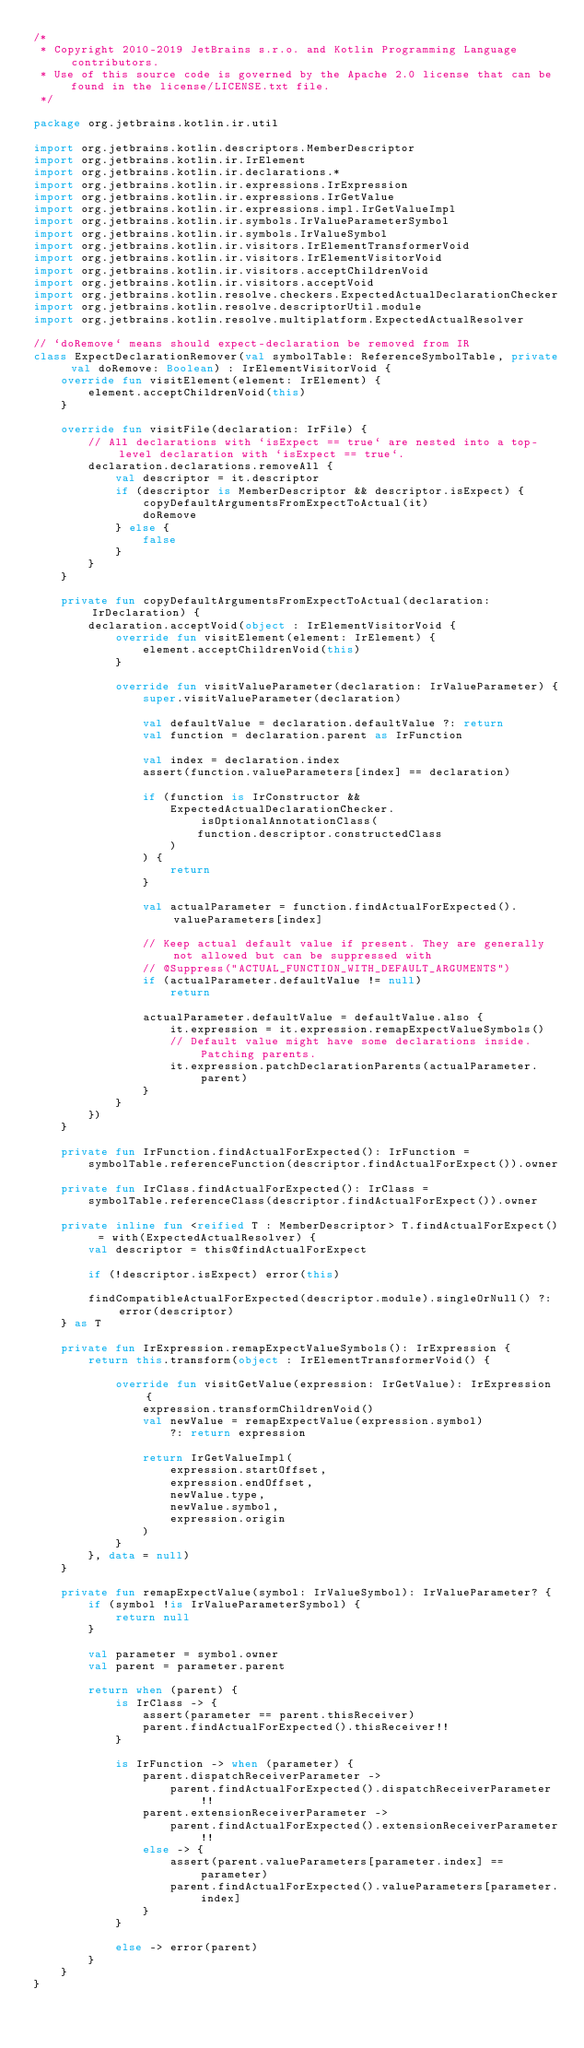<code> <loc_0><loc_0><loc_500><loc_500><_Kotlin_>/*
 * Copyright 2010-2019 JetBrains s.r.o. and Kotlin Programming Language contributors.
 * Use of this source code is governed by the Apache 2.0 license that can be found in the license/LICENSE.txt file.
 */

package org.jetbrains.kotlin.ir.util

import org.jetbrains.kotlin.descriptors.MemberDescriptor
import org.jetbrains.kotlin.ir.IrElement
import org.jetbrains.kotlin.ir.declarations.*
import org.jetbrains.kotlin.ir.expressions.IrExpression
import org.jetbrains.kotlin.ir.expressions.IrGetValue
import org.jetbrains.kotlin.ir.expressions.impl.IrGetValueImpl
import org.jetbrains.kotlin.ir.symbols.IrValueParameterSymbol
import org.jetbrains.kotlin.ir.symbols.IrValueSymbol
import org.jetbrains.kotlin.ir.visitors.IrElementTransformerVoid
import org.jetbrains.kotlin.ir.visitors.IrElementVisitorVoid
import org.jetbrains.kotlin.ir.visitors.acceptChildrenVoid
import org.jetbrains.kotlin.ir.visitors.acceptVoid
import org.jetbrains.kotlin.resolve.checkers.ExpectedActualDeclarationChecker
import org.jetbrains.kotlin.resolve.descriptorUtil.module
import org.jetbrains.kotlin.resolve.multiplatform.ExpectedActualResolver

// `doRemove` means should expect-declaration be removed from IR
class ExpectDeclarationRemover(val symbolTable: ReferenceSymbolTable, private val doRemove: Boolean) : IrElementVisitorVoid {
    override fun visitElement(element: IrElement) {
        element.acceptChildrenVoid(this)
    }

    override fun visitFile(declaration: IrFile) {
        // All declarations with `isExpect == true` are nested into a top-level declaration with `isExpect == true`.
        declaration.declarations.removeAll {
            val descriptor = it.descriptor
            if (descriptor is MemberDescriptor && descriptor.isExpect) {
                copyDefaultArgumentsFromExpectToActual(it)
                doRemove
            } else {
                false
            }
        }
    }

    private fun copyDefaultArgumentsFromExpectToActual(declaration: IrDeclaration) {
        declaration.acceptVoid(object : IrElementVisitorVoid {
            override fun visitElement(element: IrElement) {
                element.acceptChildrenVoid(this)
            }

            override fun visitValueParameter(declaration: IrValueParameter) {
                super.visitValueParameter(declaration)

                val defaultValue = declaration.defaultValue ?: return
                val function = declaration.parent as IrFunction

                val index = declaration.index
                assert(function.valueParameters[index] == declaration)

                if (function is IrConstructor &&
                    ExpectedActualDeclarationChecker.isOptionalAnnotationClass(
                        function.descriptor.constructedClass
                    )
                ) {
                    return
                }

                val actualParameter = function.findActualForExpected().valueParameters[index]

                // Keep actual default value if present. They are generally not allowed but can be suppressed with
                // @Suppress("ACTUAL_FUNCTION_WITH_DEFAULT_ARGUMENTS")
                if (actualParameter.defaultValue != null)
                    return

                actualParameter.defaultValue = defaultValue.also {
                    it.expression = it.expression.remapExpectValueSymbols()
                    // Default value might have some declarations inside. Patching parents.
                    it.expression.patchDeclarationParents(actualParameter.parent)
                }
            }
        })
    }

    private fun IrFunction.findActualForExpected(): IrFunction =
        symbolTable.referenceFunction(descriptor.findActualForExpect()).owner

    private fun IrClass.findActualForExpected(): IrClass =
        symbolTable.referenceClass(descriptor.findActualForExpect()).owner

    private inline fun <reified T : MemberDescriptor> T.findActualForExpect() = with(ExpectedActualResolver) {
        val descriptor = this@findActualForExpect

        if (!descriptor.isExpect) error(this)

        findCompatibleActualForExpected(descriptor.module).singleOrNull() ?: error(descriptor)
    } as T

    private fun IrExpression.remapExpectValueSymbols(): IrExpression {
        return this.transform(object : IrElementTransformerVoid() {

            override fun visitGetValue(expression: IrGetValue): IrExpression {
                expression.transformChildrenVoid()
                val newValue = remapExpectValue(expression.symbol)
                    ?: return expression

                return IrGetValueImpl(
                    expression.startOffset,
                    expression.endOffset,
                    newValue.type,
                    newValue.symbol,
                    expression.origin
                )
            }
        }, data = null)
    }

    private fun remapExpectValue(symbol: IrValueSymbol): IrValueParameter? {
        if (symbol !is IrValueParameterSymbol) {
            return null
        }

        val parameter = symbol.owner
        val parent = parameter.parent

        return when (parent) {
            is IrClass -> {
                assert(parameter == parent.thisReceiver)
                parent.findActualForExpected().thisReceiver!!
            }

            is IrFunction -> when (parameter) {
                parent.dispatchReceiverParameter ->
                    parent.findActualForExpected().dispatchReceiverParameter!!
                parent.extensionReceiverParameter ->
                    parent.findActualForExpected().extensionReceiverParameter!!
                else -> {
                    assert(parent.valueParameters[parameter.index] == parameter)
                    parent.findActualForExpected().valueParameters[parameter.index]
                }
            }

            else -> error(parent)
        }
    }
}</code> 